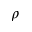Convert formula to latex. <formula><loc_0><loc_0><loc_500><loc_500>\rho</formula> 